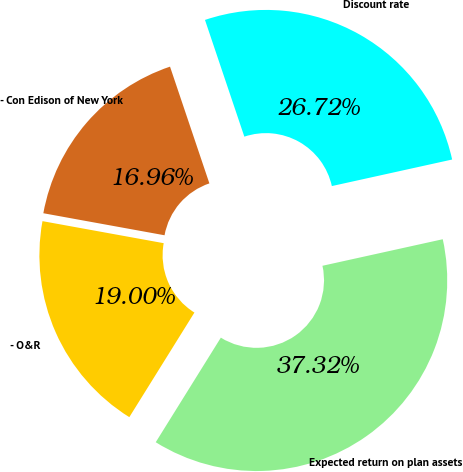Convert chart to OTSL. <chart><loc_0><loc_0><loc_500><loc_500><pie_chart><fcel>Discount rate<fcel>- Con Edison of New York<fcel>- O&R<fcel>Expected return on plan assets<nl><fcel>26.72%<fcel>16.96%<fcel>19.0%<fcel>37.32%<nl></chart> 